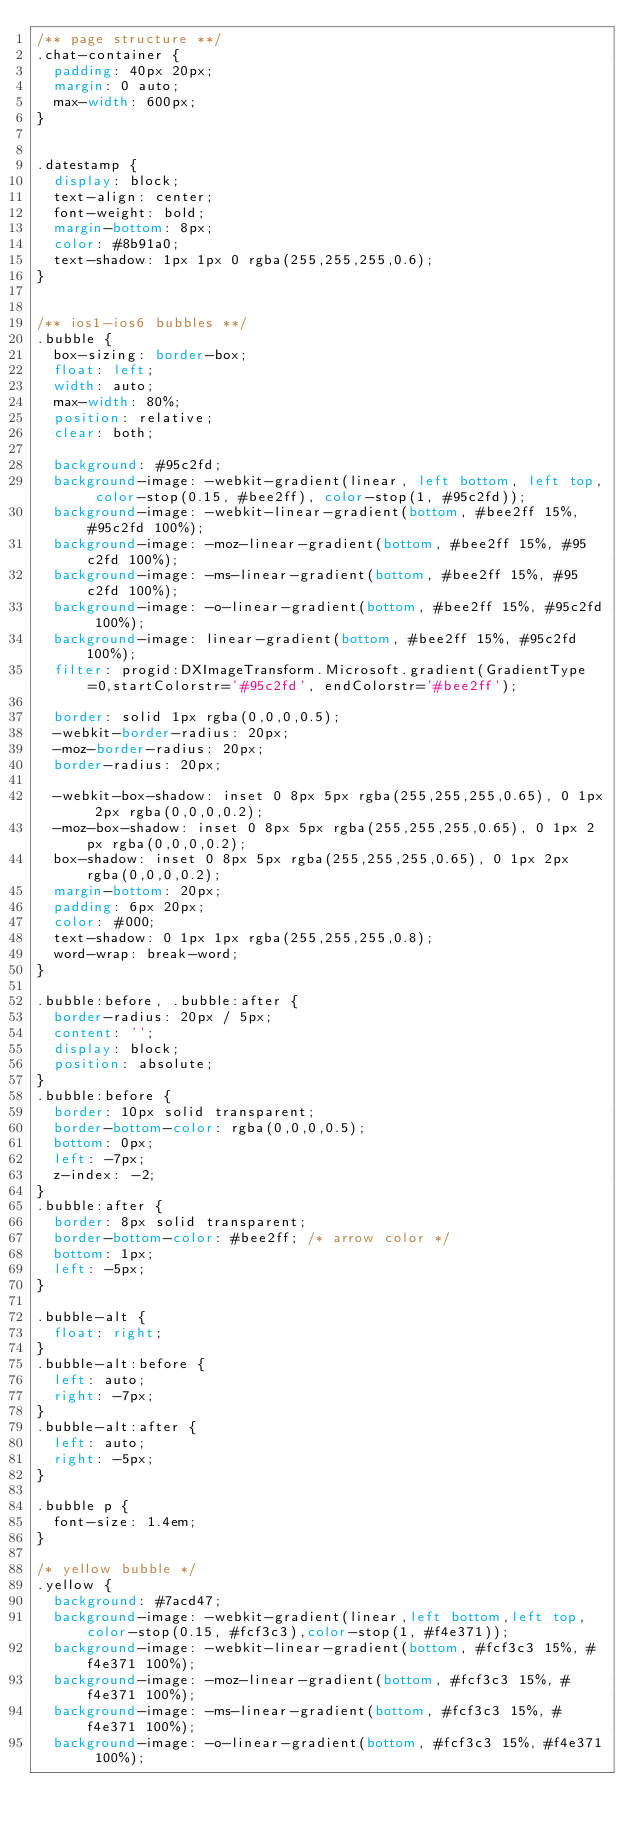Convert code to text. <code><loc_0><loc_0><loc_500><loc_500><_CSS_>/** page structure **/
.chat-container {
  padding: 40px 20px;
  margin: 0 auto;
  max-width: 600px;
}
 
 
.datestamp {
  display: block;
  text-align: center;
  font-weight: bold;
  margin-bottom: 8px;
  color: #8b91a0;
  text-shadow: 1px 1px 0 rgba(255,255,255,0.6);
}
 
 
/** ios1-ios6 bubbles **/
.bubble {
  box-sizing: border-box;
  float: left;
  width: auto;
  max-width: 80%;
  position: relative;
  clear: both;
 
  background: #95c2fd;
  background-image: -webkit-gradient(linear, left bottom, left top, color-stop(0.15, #bee2ff), color-stop(1, #95c2fd));
  background-image: -webkit-linear-gradient(bottom, #bee2ff 15%, #95c2fd 100%);
  background-image: -moz-linear-gradient(bottom, #bee2ff 15%, #95c2fd 100%);
  background-image: -ms-linear-gradient(bottom, #bee2ff 15%, #95c2fd 100%);
  background-image: -o-linear-gradient(bottom, #bee2ff 15%, #95c2fd 100%);
  background-image: linear-gradient(bottom, #bee2ff 15%, #95c2fd 100%);
  filter: progid:DXImageTransform.Microsoft.gradient(GradientType=0,startColorstr='#95c2fd', endColorstr='#bee2ff');
 
  border: solid 1px rgba(0,0,0,0.5);
  -webkit-border-radius: 20px;
  -moz-border-radius: 20px;
  border-radius: 20px;
 
  -webkit-box-shadow: inset 0 8px 5px rgba(255,255,255,0.65), 0 1px 2px rgba(0,0,0,0.2);
  -moz-box-shadow: inset 0 8px 5px rgba(255,255,255,0.65), 0 1px 2px rgba(0,0,0,0.2);
  box-shadow: inset 0 8px 5px rgba(255,255,255,0.65), 0 1px 2px rgba(0,0,0,0.2);
  margin-bottom: 20px;
  padding: 6px 20px;
  color: #000;
  text-shadow: 0 1px 1px rgba(255,255,255,0.8);
  word-wrap: break-word;
}

.bubble:before, .bubble:after {
  border-radius: 20px / 5px;
  content: '';
  display: block;
  position: absolute;
}
.bubble:before {
  border: 10px solid transparent;
  border-bottom-color: rgba(0,0,0,0.5);
  bottom: 0px;
  left: -7px;
  z-index: -2;
}
.bubble:after {
  border: 8px solid transparent;
  border-bottom-color: #bee2ff; /* arrow color */
  bottom: 1px;
  left: -5px;
}

.bubble-alt {
  float: right;
}
.bubble-alt:before {
  left: auto;
  right: -7px;
}
.bubble-alt:after {
  left: auto;
  right: -5px;
}
 
.bubble p {
  font-size: 1.4em;
}

/* yellow bubble */
.yellow {
  background: #7acd47;
  background-image: -webkit-gradient(linear,left bottom,left top,color-stop(0.15, #fcf3c3),color-stop(1, #f4e371));
  background-image: -webkit-linear-gradient(bottom, #fcf3c3 15%, #f4e371 100%);
  background-image: -moz-linear-gradient(bottom, #fcf3c3 15%, #f4e371 100%);
  background-image: -ms-linear-gradient(bottom, #fcf3c3 15%, #f4e371 100%);
  background-image: -o-linear-gradient(bottom, #fcf3c3 15%, #f4e371 100%);</code> 